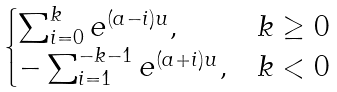Convert formula to latex. <formula><loc_0><loc_0><loc_500><loc_500>\begin{cases} \sum _ { i = 0 } ^ { k } e ^ { ( a - i ) u } , & k \geq 0 \\ - \sum _ { i = 1 } ^ { - k - 1 } e ^ { ( a + i ) u } , & k < 0 \end{cases}</formula> 